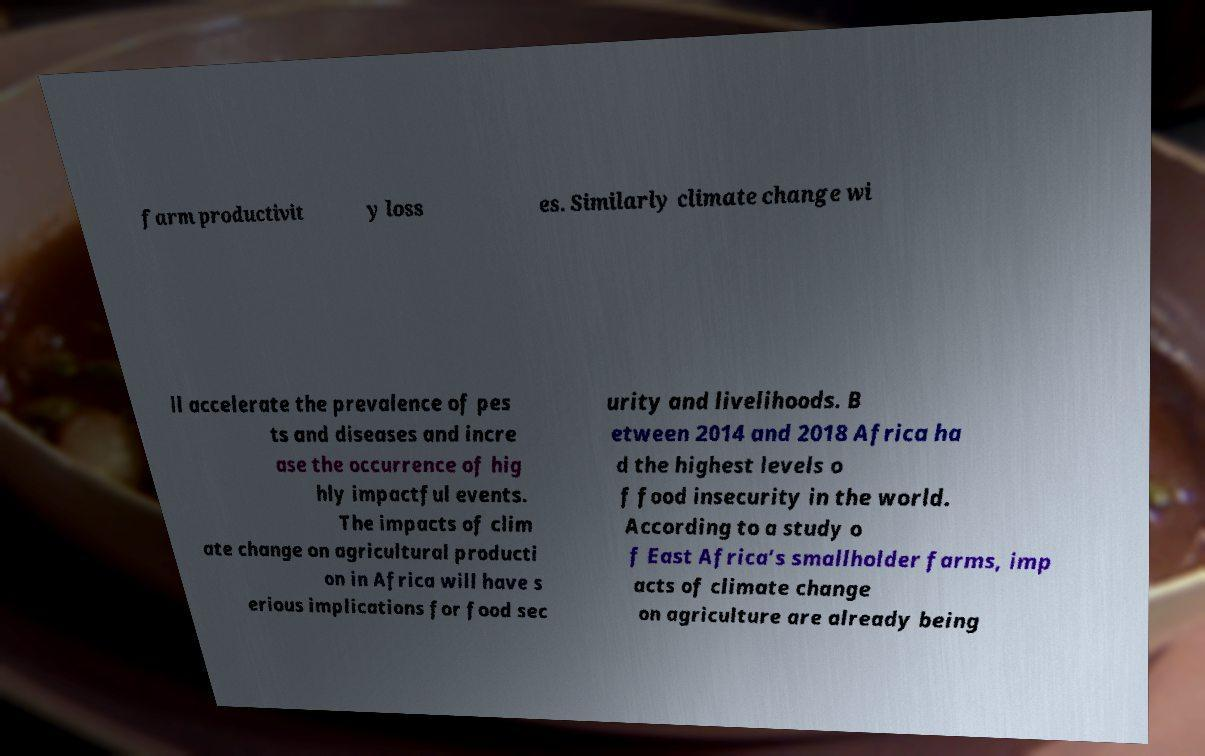Please identify and transcribe the text found in this image. farm productivit y loss es. Similarly climate change wi ll accelerate the prevalence of pes ts and diseases and incre ase the occurrence of hig hly impactful events. The impacts of clim ate change on agricultural producti on in Africa will have s erious implications for food sec urity and livelihoods. B etween 2014 and 2018 Africa ha d the highest levels o f food insecurity in the world. According to a study o f East Africa’s smallholder farms, imp acts of climate change on agriculture are already being 